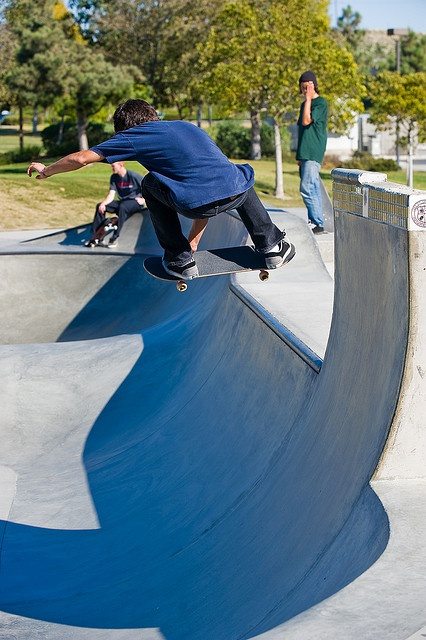Describe the objects in this image and their specific colors. I can see people in darkgray, black, blue, navy, and gray tones, people in darkgray, teal, black, and gray tones, skateboard in darkgray, black, and gray tones, people in darkgray, black, navy, gray, and lightgray tones, and skateboard in darkgray, black, gray, maroon, and white tones in this image. 